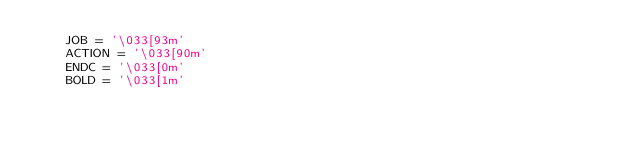<code> <loc_0><loc_0><loc_500><loc_500><_Python_>    JOB = '\033[93m'
    ACTION = '\033[90m'
    ENDC = '\033[0m'
    BOLD = '\033[1m'
</code> 